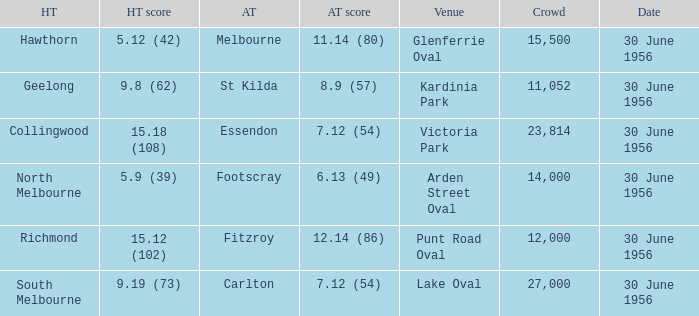What is the home team score when the away team is St Kilda? 9.8 (62). 